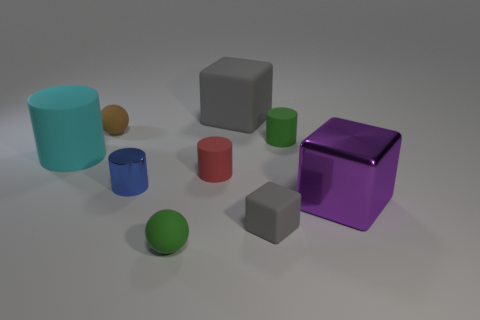There is another block that is the same color as the small cube; what size is it?
Give a very brief answer. Large. What shape is the matte thing that is the same color as the tiny rubber block?
Keep it short and to the point. Cube. Are there any other things that are the same color as the large rubber cube?
Your answer should be compact. Yes. How many small things are right of the shiny cylinder and behind the tiny matte block?
Provide a short and direct response. 2. Is there a large gray thing that is to the left of the rubber ball behind the green rubber object behind the large purple shiny cube?
Your answer should be compact. No. What shape is the red object that is the same size as the brown matte object?
Your response must be concise. Cylinder. Are there any small cubes that have the same color as the large matte cube?
Give a very brief answer. Yes. Does the large gray thing have the same shape as the tiny red thing?
Give a very brief answer. No. How many big things are blocks or blue metallic objects?
Your answer should be compact. 2. The small block that is made of the same material as the brown sphere is what color?
Ensure brevity in your answer.  Gray. 